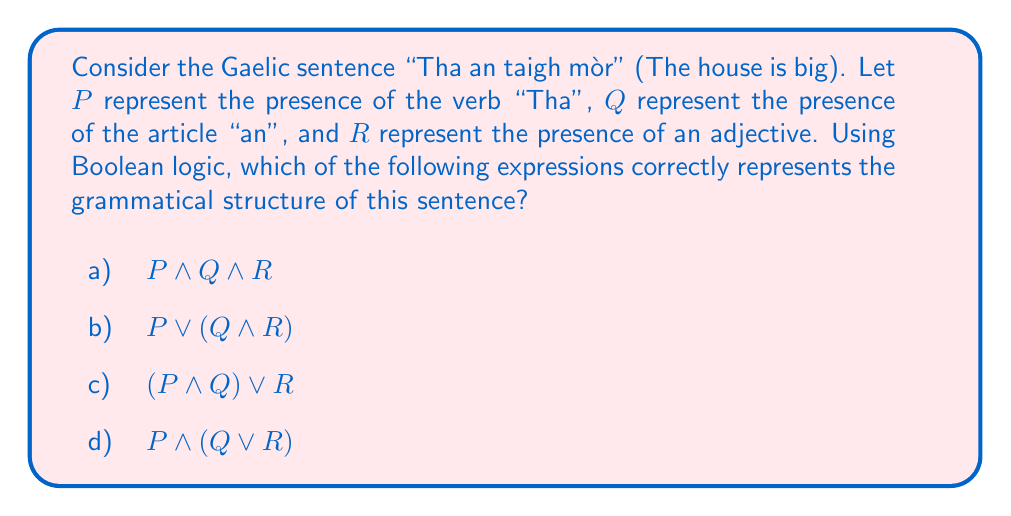Show me your answer to this math problem. Let's analyze the sentence structure step by step:

1) First, we identify the components:
   - $P$: "Tha" (verb) is present
   - $Q$: "an" (article) is present
   - $R$: An adjective ("mòr") is present

2) In Gaelic, the verb typically comes at the beginning of the sentence, followed by the subject (which may include an article), and then any adjectives or modifiers.

3) All three components are present in the sentence, and they must all be true for the sentence to be grammatically correct.

4) In Boolean logic, the AND operation ($\land$) is used when all conditions must be true.

5) Therefore, the correct expression would be $P \land Q \land R$, as all three elements must be present and in the correct order for the sentence to be grammatically correct.

6) Options b, c, and d all include OR operations ($\lor$), which would allow for some elements to be missing, which is not the case in this grammatically correct sentence.
Answer: a) $P \land Q \land R$ 